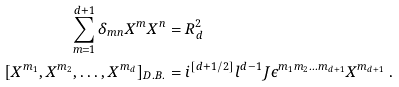Convert formula to latex. <formula><loc_0><loc_0><loc_500><loc_500>\sum _ { m = 1 } ^ { d + 1 } \delta _ { m n } X ^ { m } X ^ { n } & = R _ { d } ^ { 2 } \\ [ X ^ { m _ { 1 } } , X ^ { m _ { 2 } } , \dots , X ^ { m _ { d } } ] _ { D . B . } & = i ^ { [ d + 1 / 2 ] } l ^ { d - 1 } J \epsilon ^ { m _ { 1 } m _ { 2 } \dots m _ { d + 1 } } X ^ { m _ { d + 1 } } \ .</formula> 